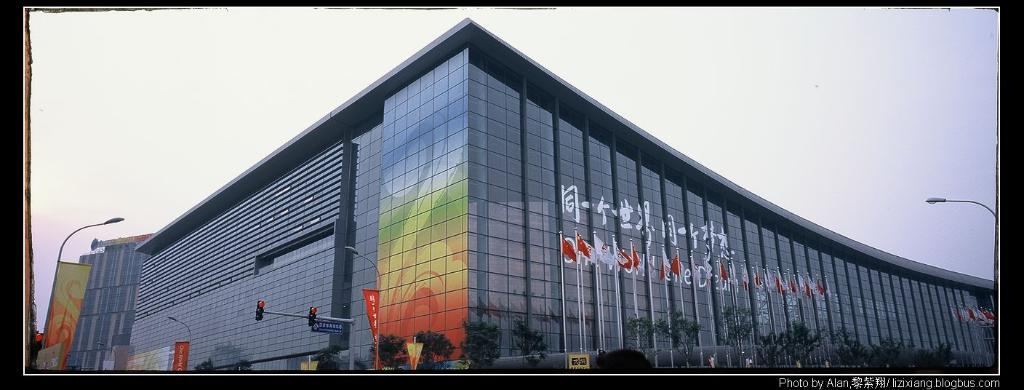What type of building can be seen in the image? There is a glass building in the image. What is used to control traffic in the image? There is a traffic signal in the image. What are the sign boards used for in the image? The sign boards are used for providing information or directions in the image. What are the light-poles used for in the image? The light-poles are used for providing illumination in the image. What type of vegetation is present in the image? Trees are present in the image. What are the banners used for in the image? The banners are used for advertising or conveying messages in the image. What is the color of the sky in the image? The sky appears to be white in color in the image. Can you see the queen shaking hands with someone in the image? There is no queen or anyone shaking hands in the image; it features a glass building, a traffic signal, sign boards, light-poles, trees, banners, and a white sky. What type of blade is being used to cut the trees in the image? There is no blade or tree-cutting activity in the image; it features a glass building, a traffic signal, sign boards, light-poles, trees, banners, and a white sky. 